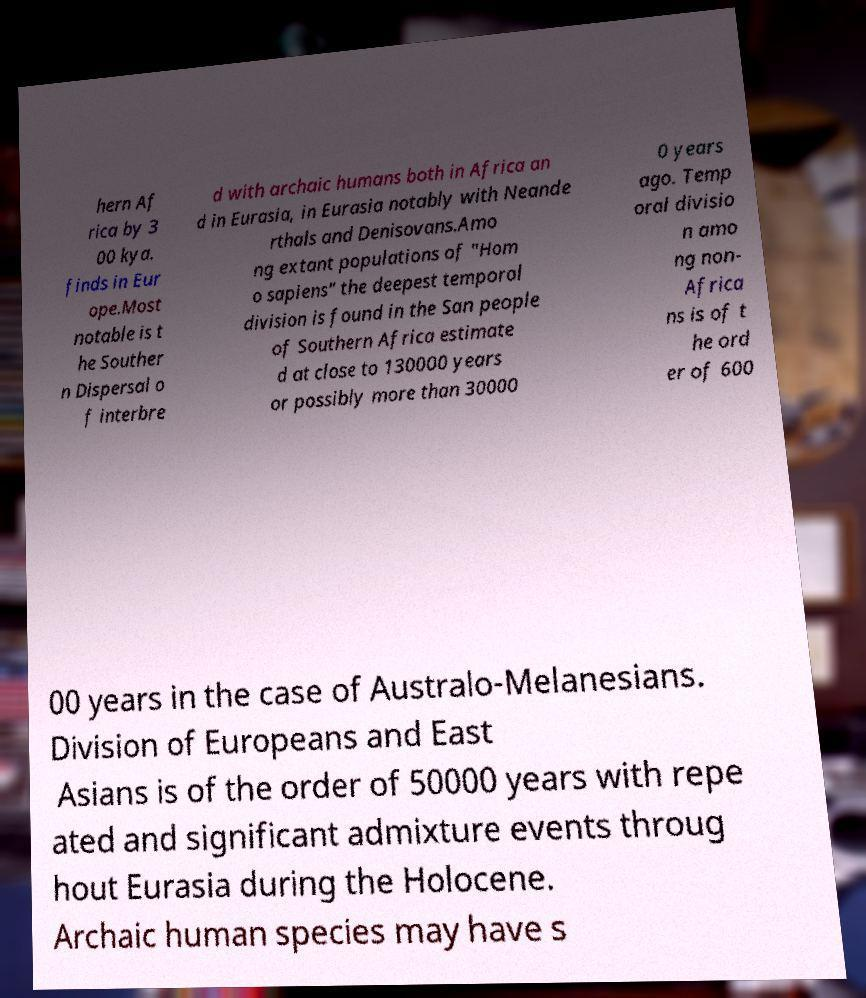Please identify and transcribe the text found in this image. hern Af rica by 3 00 kya. finds in Eur ope.Most notable is t he Souther n Dispersal o f interbre d with archaic humans both in Africa an d in Eurasia, in Eurasia notably with Neande rthals and Denisovans.Amo ng extant populations of "Hom o sapiens" the deepest temporal division is found in the San people of Southern Africa estimate d at close to 130000 years or possibly more than 30000 0 years ago. Temp oral divisio n amo ng non- Africa ns is of t he ord er of 600 00 years in the case of Australo-Melanesians. Division of Europeans and East Asians is of the order of 50000 years with repe ated and significant admixture events throug hout Eurasia during the Holocene. Archaic human species may have s 